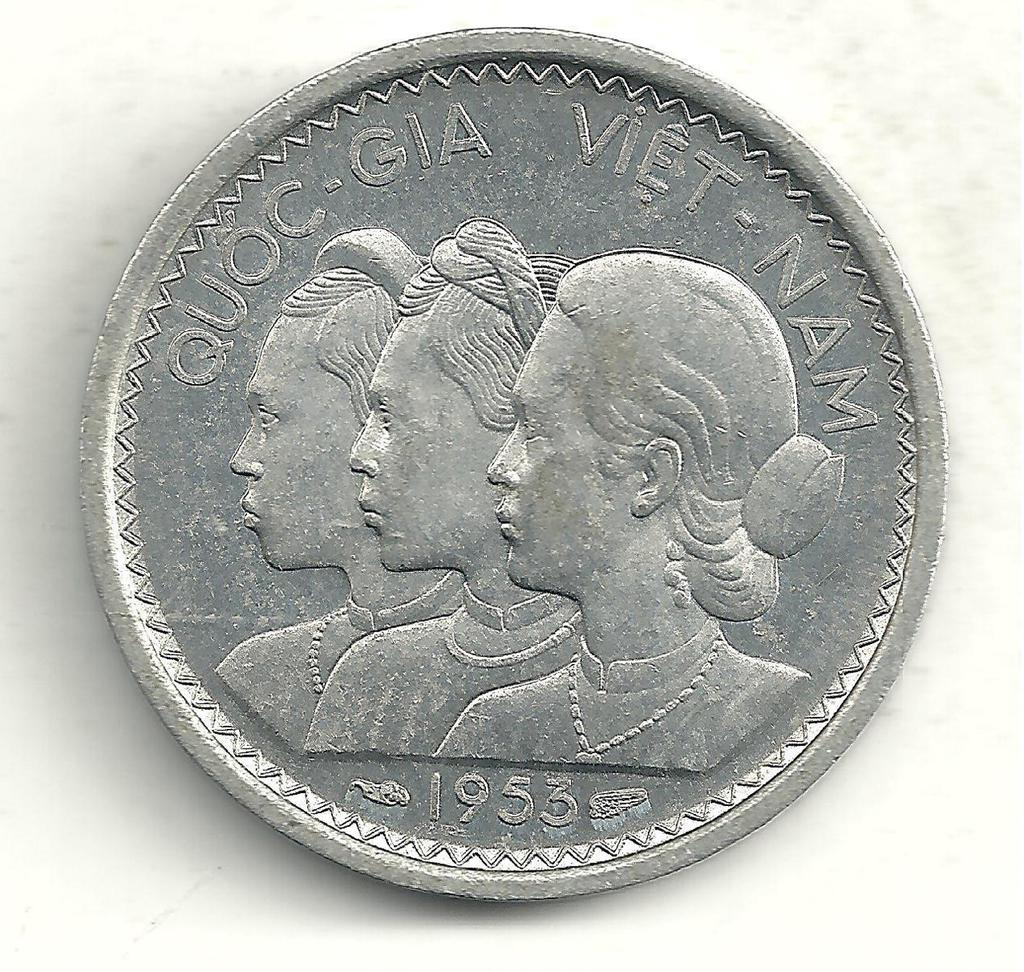<image>
Render a clear and concise summary of the photo. Quoc gia vietnam silver coin with three ladies on the front 